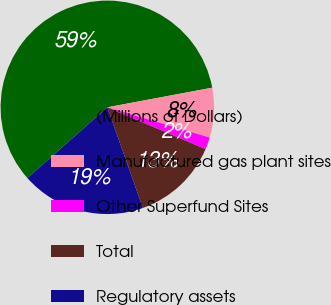Convert chart to OTSL. <chart><loc_0><loc_0><loc_500><loc_500><pie_chart><fcel>(Millions of Dollars)<fcel>Manufactured gas plant sites<fcel>Other Superfund Sites<fcel>Total<fcel>Regulatory assets<nl><fcel>58.59%<fcel>7.52%<fcel>1.84%<fcel>13.19%<fcel>18.87%<nl></chart> 